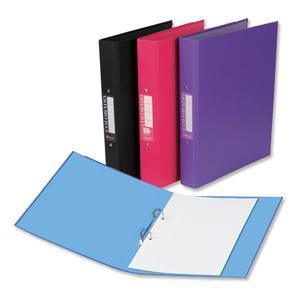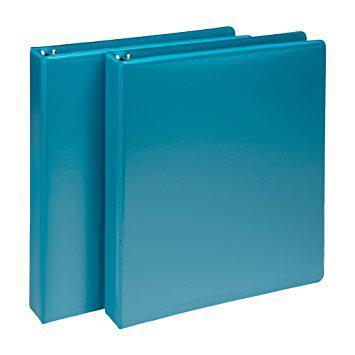The first image is the image on the left, the second image is the image on the right. Analyze the images presented: Is the assertion "There are two binders in total." valid? Answer yes or no. No. The first image is the image on the left, the second image is the image on the right. Analyze the images presented: Is the assertion "Exactly two ring binder notebooks with plastic cover, each a different color, are standing on end, at least one of them empty." valid? Answer yes or no. No. 